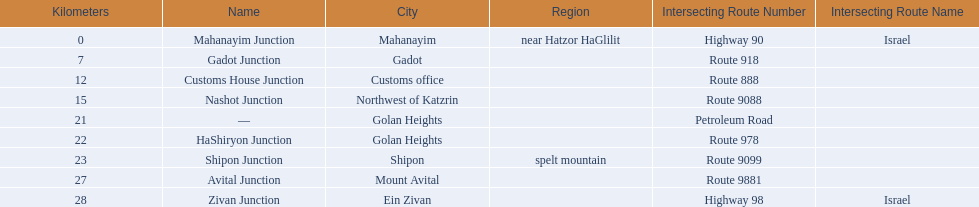What are all the are all the locations on the highway 91 (israel)? Mahanayim, near Hatzor HaGlilit, Gadot, Customs office, Northwest of Katzrin, Golan Heights, Golan Heights, Shipon (spelt) mountain, Mount Avital, Ein Zivan. What are the distance values in kilometers for ein zivan, gadot junction and shipon junction? 7, 23, 28. Which is the least distance away? 7. What is the name? Gadot Junction. 